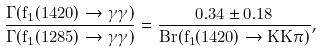Convert formula to latex. <formula><loc_0><loc_0><loc_500><loc_500>\frac { \Gamma ( f _ { 1 } ( 1 4 2 0 ) \rightarrow \gamma \gamma ) } { \Gamma ( f _ { 1 } ( 1 2 8 5 ) \rightarrow \gamma \gamma ) } = \frac { 0 . 3 4 \pm 0 . 1 8 } { B r ( f _ { 1 } ( 1 4 2 0 ) \rightarrow K \bar { K } \pi ) } ,</formula> 